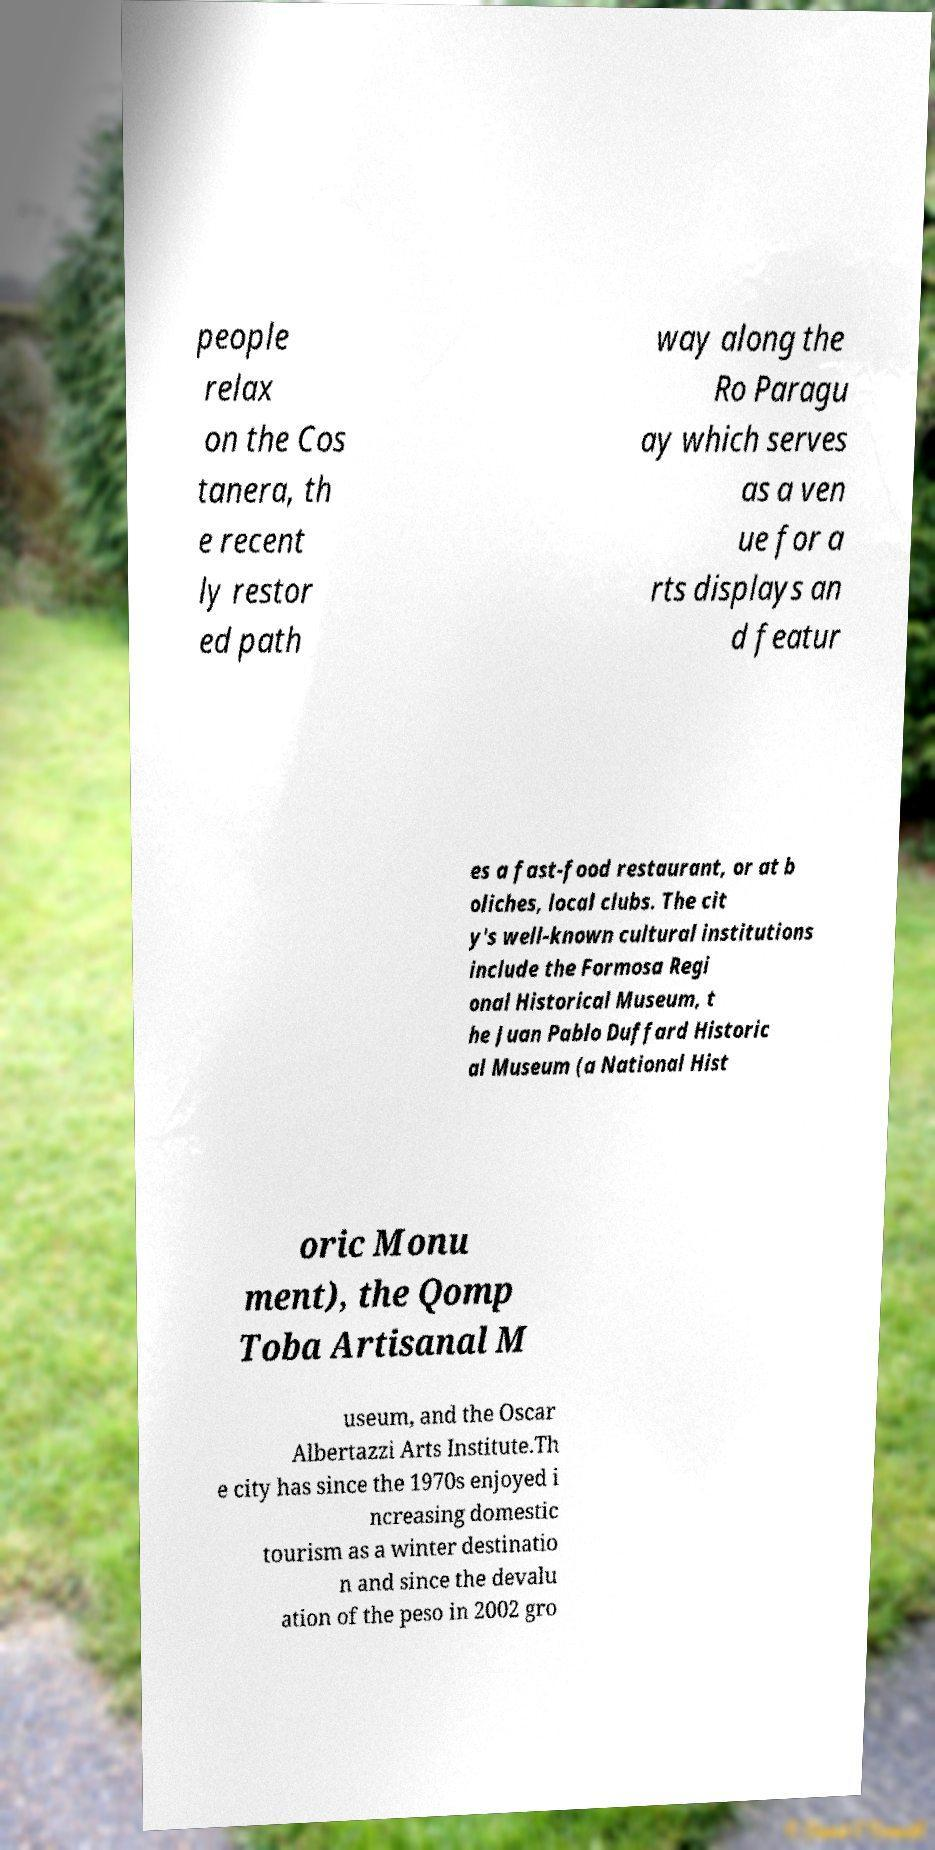Can you read and provide the text displayed in the image?This photo seems to have some interesting text. Can you extract and type it out for me? people relax on the Cos tanera, th e recent ly restor ed path way along the Ro Paragu ay which serves as a ven ue for a rts displays an d featur es a fast-food restaurant, or at b oliches, local clubs. The cit y's well-known cultural institutions include the Formosa Regi onal Historical Museum, t he Juan Pablo Duffard Historic al Museum (a National Hist oric Monu ment), the Qomp Toba Artisanal M useum, and the Oscar Albertazzi Arts Institute.Th e city has since the 1970s enjoyed i ncreasing domestic tourism as a winter destinatio n and since the devalu ation of the peso in 2002 gro 